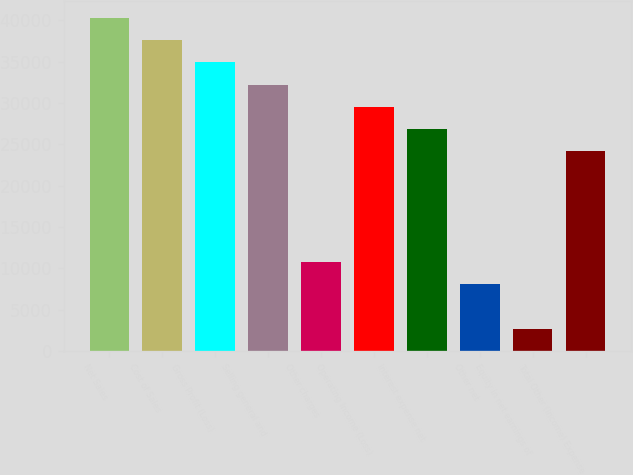Convert chart. <chart><loc_0><loc_0><loc_500><loc_500><bar_chart><fcel>Net Sales<fcel>Cost of Sales<fcel>Gross Profit (Loss)<fcel>Selling general and<fcel>Other charges<fcel>Operating Income (Loss)<fcel>Interest expense net<fcel>Other net<fcel>Equity in net earnings of<fcel>Total Other (Income) Expense<nl><fcel>40292.2<fcel>37606.2<fcel>34920.2<fcel>32234.1<fcel>10745.7<fcel>29548.1<fcel>26862<fcel>8059.69<fcel>2687.6<fcel>24176<nl></chart> 